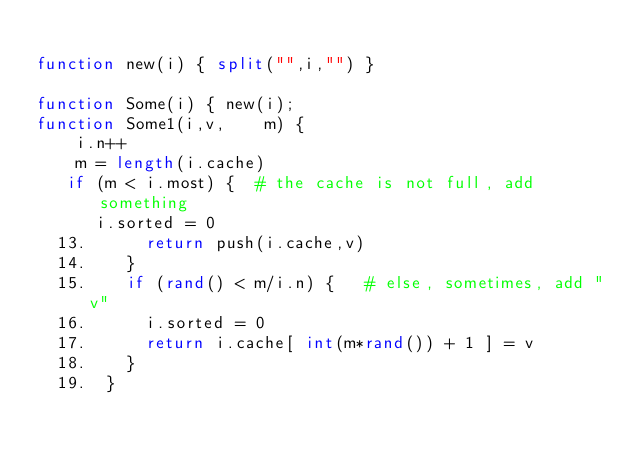Convert code to text. <code><loc_0><loc_0><loc_500><loc_500><_Awk_>
function new(i) { split("",i,"") }

function Some(i) { new(i); 
function Some1(i,v,    m) {
    i.n++
    m = length(i.cache)
   if (m < i.most) {  # the cache is not full, add something
      i.sorted = 0
  13.      return push(i.cache,v)
  14.    }
  15.    if (rand() < m/i.n) {   # else, sometimes, add "v"
  16.      i.sorted = 0
  17.      return i.cache[ int(m*rand()) + 1 ] = v
  18.    }
  19.  }

</code> 